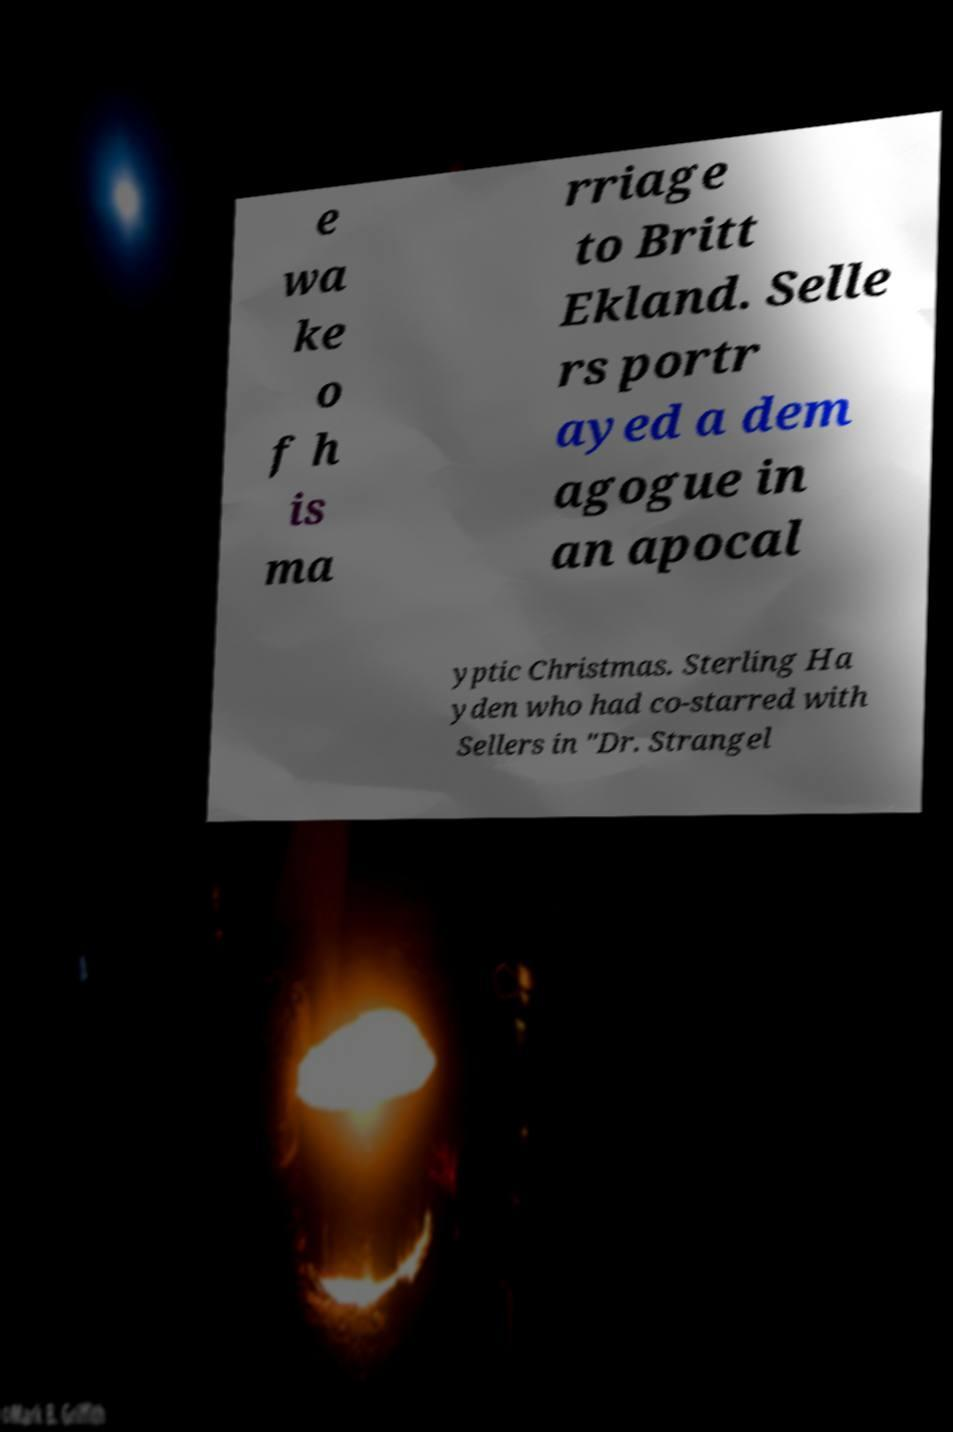Could you extract and type out the text from this image? e wa ke o f h is ma rriage to Britt Ekland. Selle rs portr ayed a dem agogue in an apocal yptic Christmas. Sterling Ha yden who had co-starred with Sellers in "Dr. Strangel 